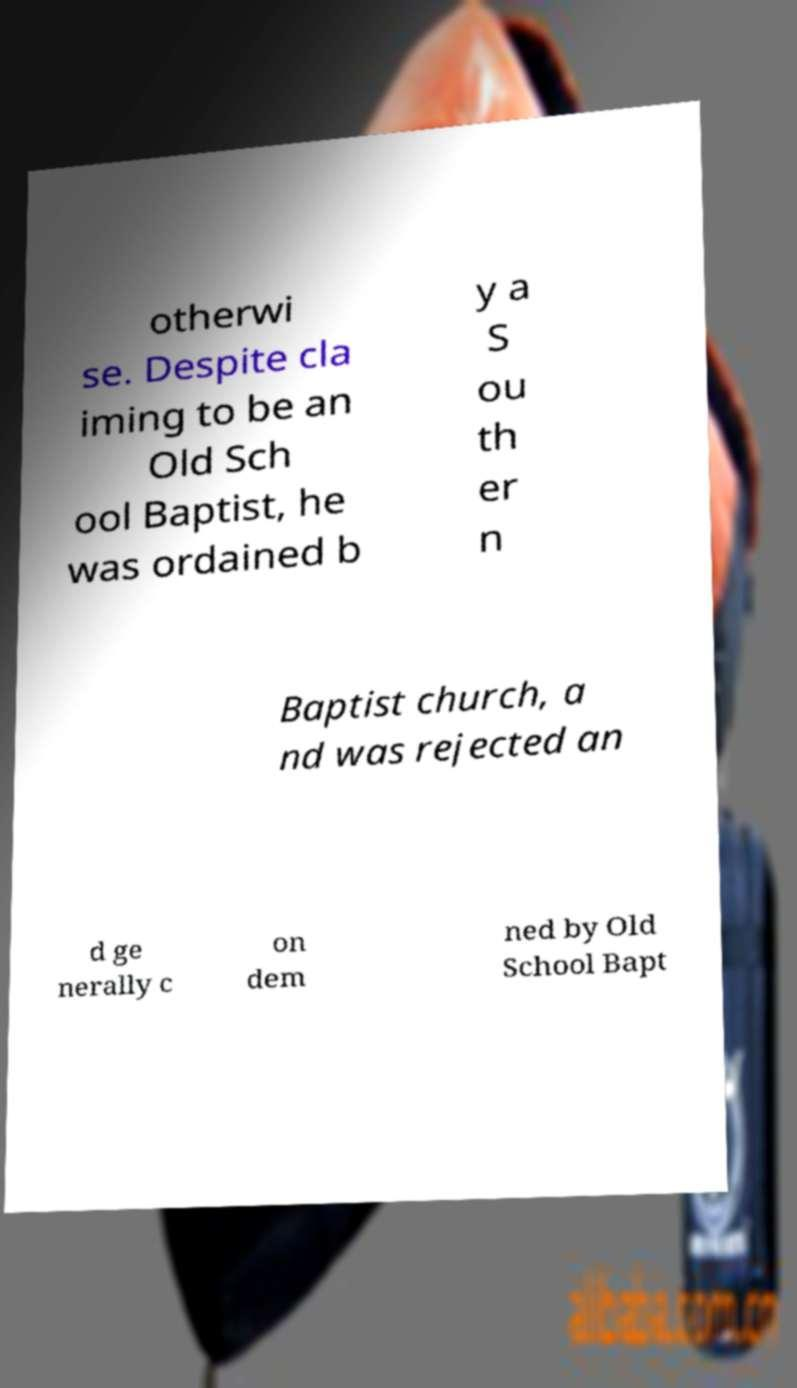There's text embedded in this image that I need extracted. Can you transcribe it verbatim? otherwi se. Despite cla iming to be an Old Sch ool Baptist, he was ordained b y a S ou th er n Baptist church, a nd was rejected an d ge nerally c on dem ned by Old School Bapt 